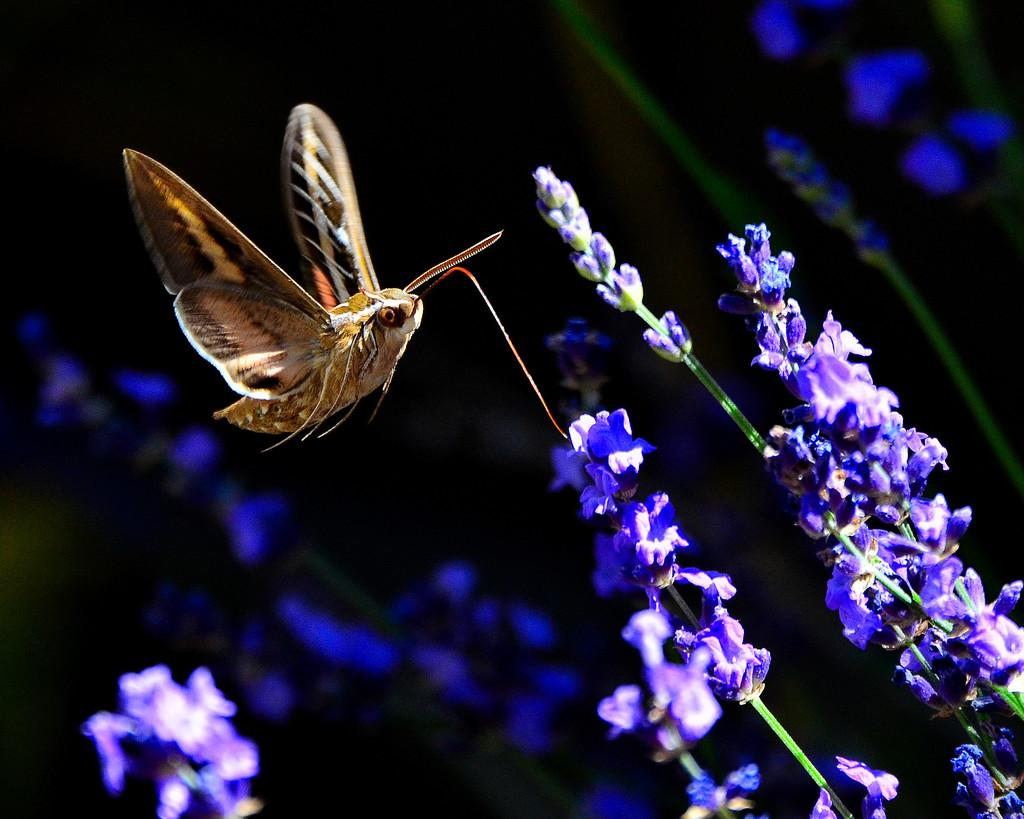What is the main subject of the image? There is a butterfly in the image. What is the butterfly doing in the image? The butterfly is flying. What type of vegetation is present in the image? There are tiny flowers in the image. What is the color of the flowers? The flowers are purple in color. What part of the flower can be seen in the image? The stem of the flower is visible. What is the color of the background in the image? The background of the image is dark. Can you see a seashore in the image? No, there is no seashore present in the image. What type of badge is the butterfly wearing in the image? There is no badge present on the butterfly in the image. 